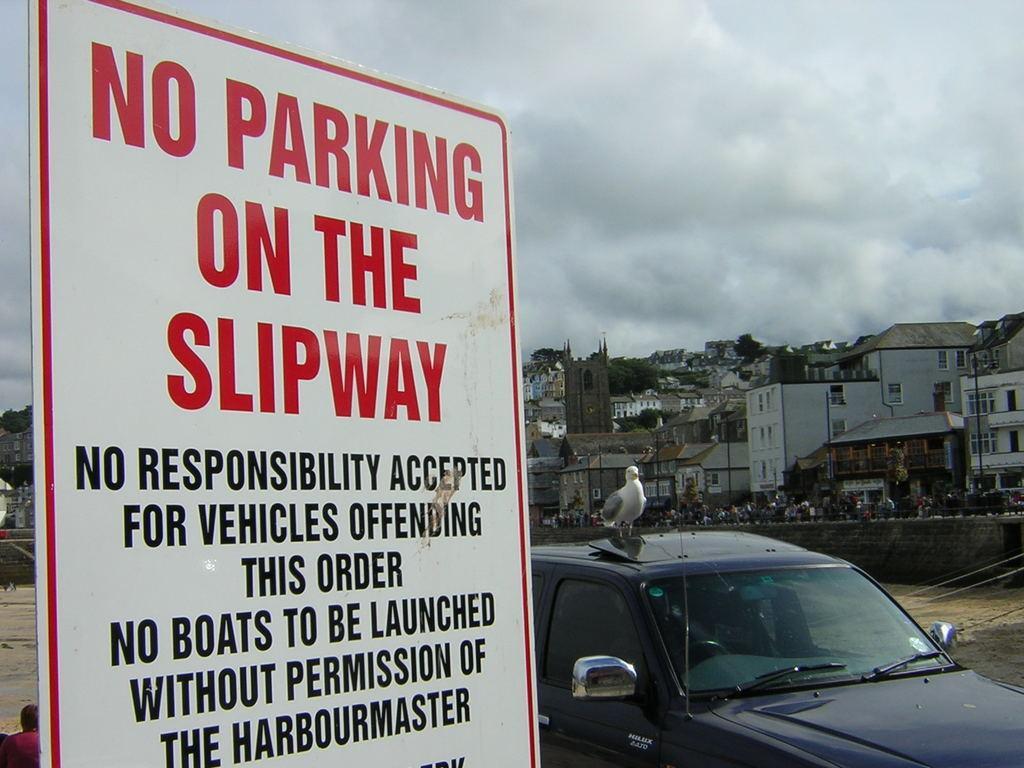Can you describe this image briefly? In this picture we can see a sign board, and a bird on the car, in the background we can find few poles, trees, buildings and people. 